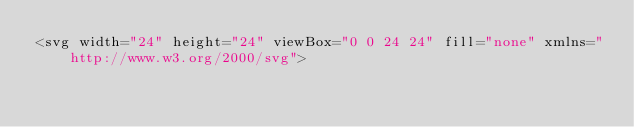Convert code to text. <code><loc_0><loc_0><loc_500><loc_500><_PHP_><svg width="24" height="24" viewBox="0 0 24 24" fill="none" xmlns="http://www.w3.org/2000/svg"></code> 